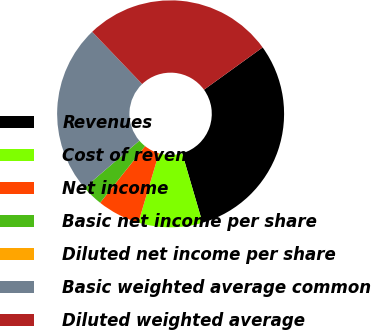Convert chart to OTSL. <chart><loc_0><loc_0><loc_500><loc_500><pie_chart><fcel>Revenues<fcel>Cost of revenues<fcel>Net income<fcel>Basic net income per share<fcel>Diluted net income per share<fcel>Basic weighted average common<fcel>Diluted weighted average<nl><fcel>30.41%<fcel>9.12%<fcel>6.08%<fcel>3.04%<fcel>0.0%<fcel>24.15%<fcel>27.19%<nl></chart> 